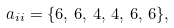Convert formula to latex. <formula><loc_0><loc_0><loc_500><loc_500>a _ { i i } = \{ 6 , \, 6 , \, 4 , \, 4 , \, 6 , \, 6 \} ,</formula> 